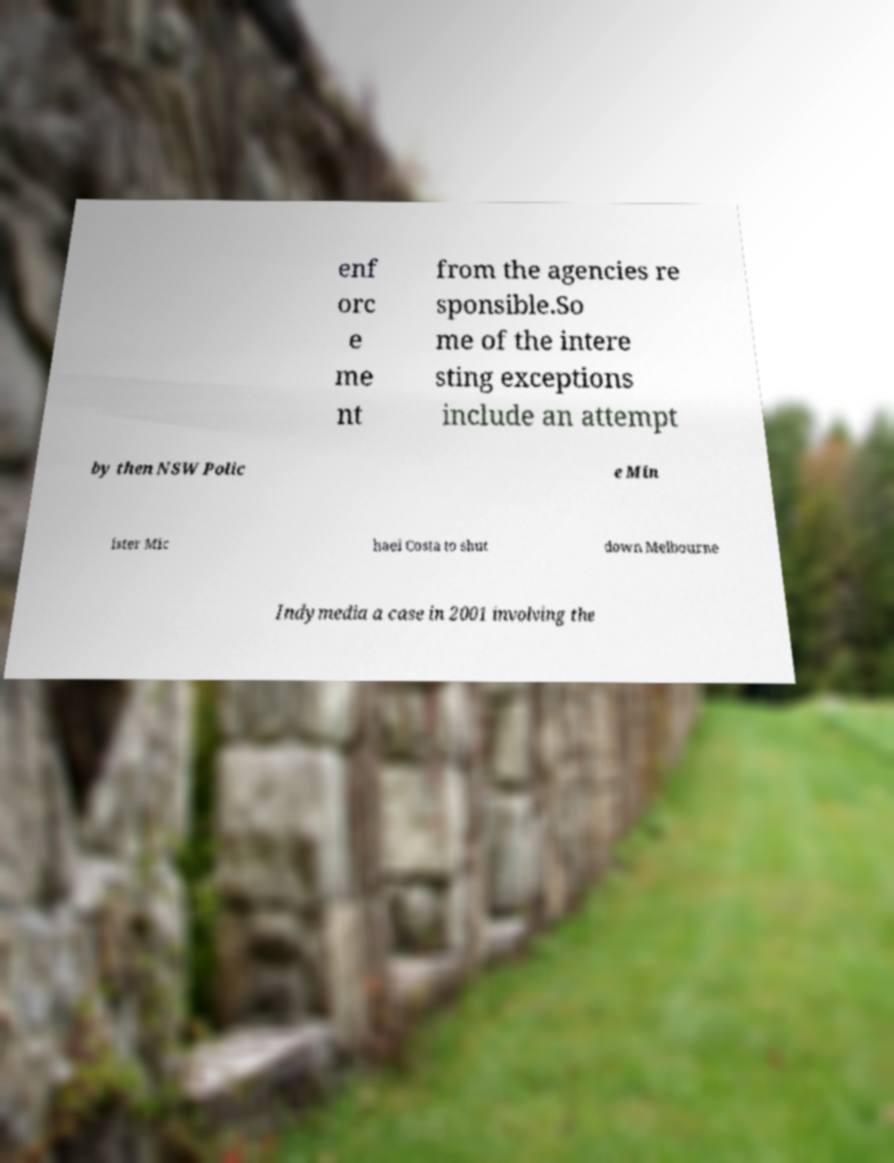Can you read and provide the text displayed in the image?This photo seems to have some interesting text. Can you extract and type it out for me? enf orc e me nt from the agencies re sponsible.So me of the intere sting exceptions include an attempt by then NSW Polic e Min ister Mic hael Costa to shut down Melbourne Indymedia a case in 2001 involving the 